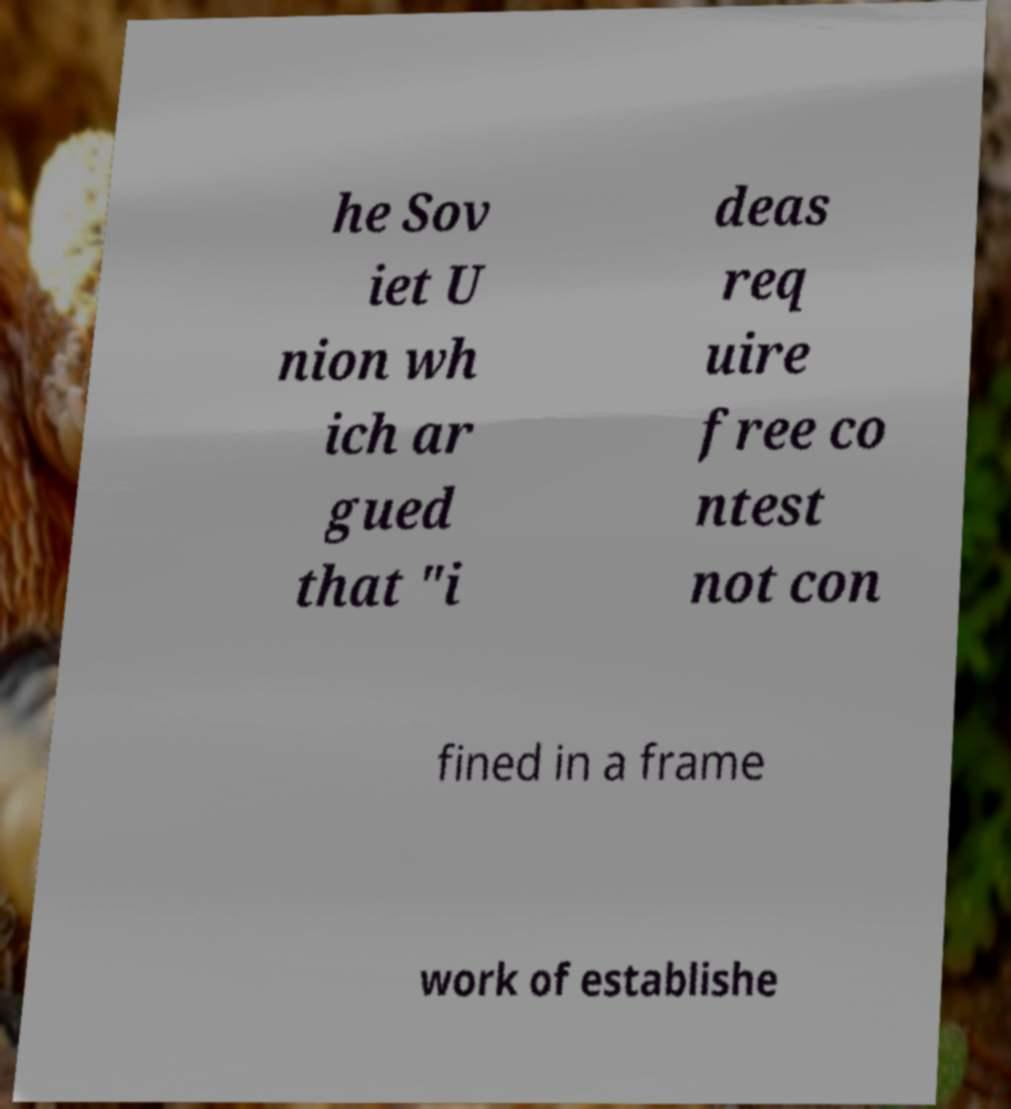Could you extract and type out the text from this image? he Sov iet U nion wh ich ar gued that "i deas req uire free co ntest not con fined in a frame work of establishe 